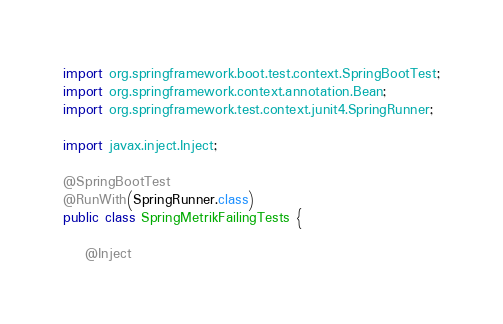Convert code to text. <code><loc_0><loc_0><loc_500><loc_500><_Java_>import org.springframework.boot.test.context.SpringBootTest;
import org.springframework.context.annotation.Bean;
import org.springframework.test.context.junit4.SpringRunner;

import javax.inject.Inject;

@SpringBootTest
@RunWith(SpringRunner.class)
public class SpringMetrikFailingTests {

    @Inject</code> 